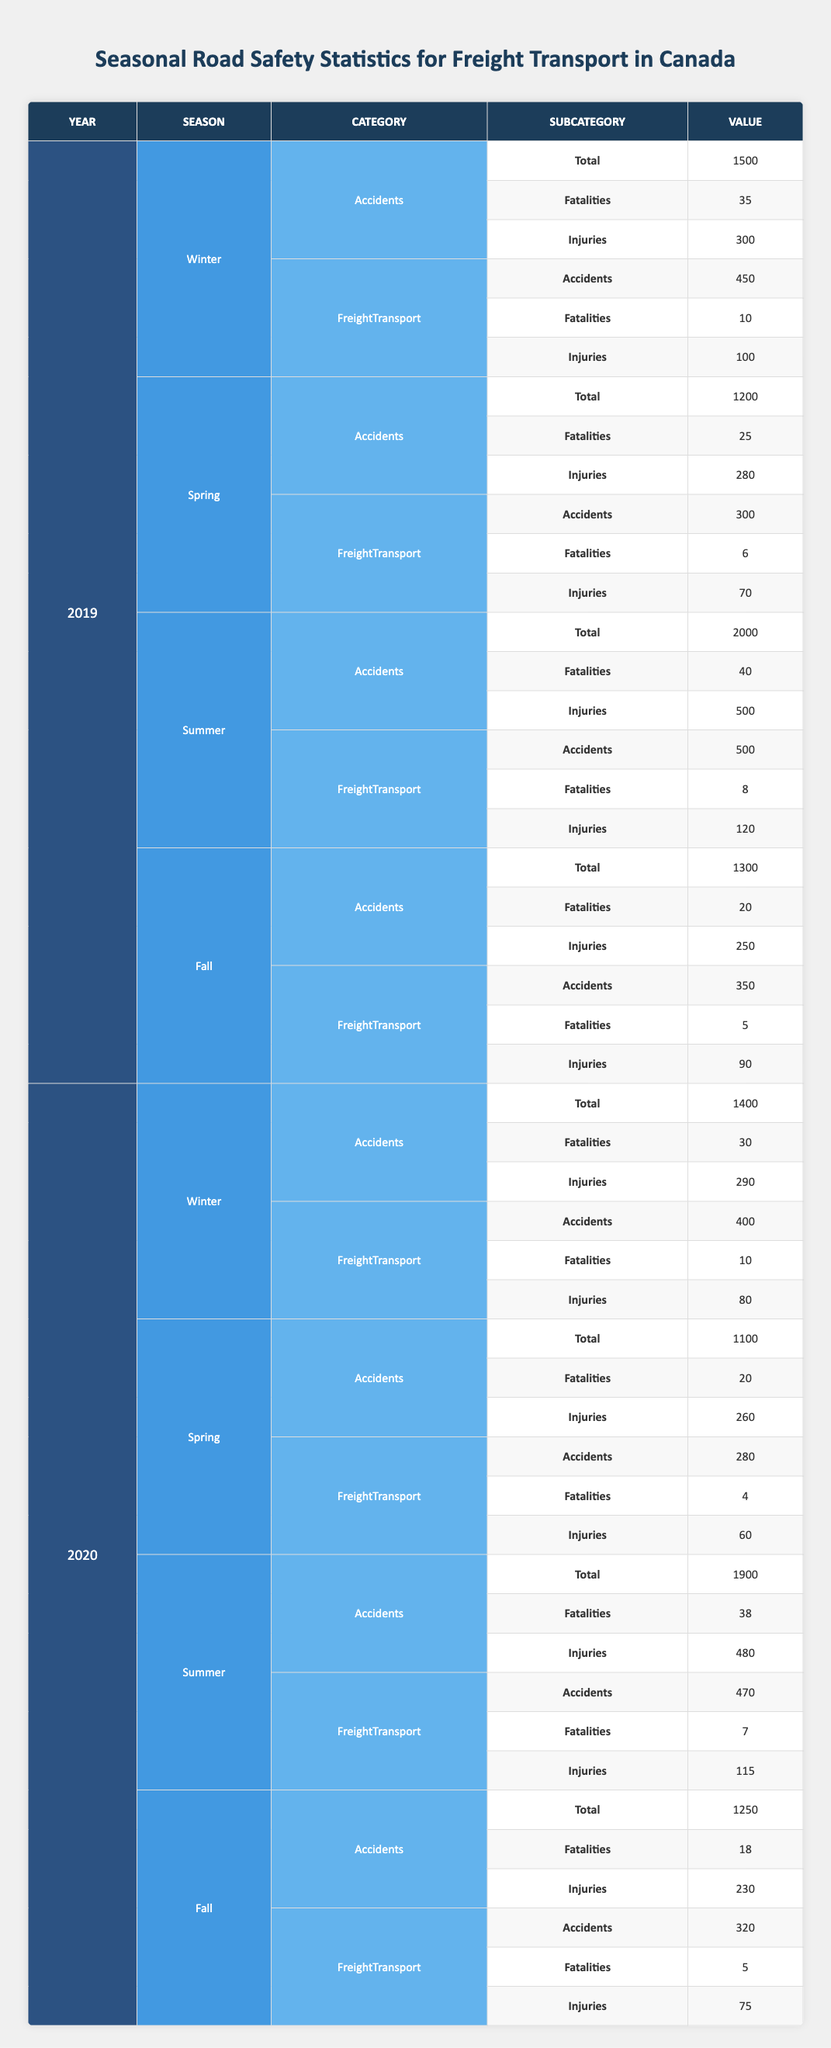What was the total number of freight transport accidents in summer 2019? In summer 2019, the table shows that the number of freight transport accidents was 500.
Answer: 500 How many fatalities were recorded for freight transport in winter 2020? According to the table, there were 10 fatalities in freight transport during winter 2020.
Answer: 10 What season had the highest number of total accidents in 2020? Looking at the total accidents for 2020 in each season, summer had the highest number with 1900 accidents.
Answer: Summer What is the total number of injuries from freight transport in 2019 across all seasons? Summing the injuries from freight transport in 2019: winter (100) + spring (70) + summer (120) + fall (90) gives a total of 380 injuries.
Answer: 380 Was there a decrease in the number of freight transport accidents from 2019 to 2020? By comparing the total freight transport accidents, 2019 had 1600 accidents (450 + 300 + 500 + 350) and 2020 had 1470 accidents (400 + 280 + 470 + 320), indicating a decrease.
Answer: Yes What was the average number of injuries in freight transport during fall across both years? The injuries in fall were 90 in 2019 and 75 in 2020. To calculate the average: (90 + 75) / 2 = 82.5.
Answer: 82.5 In which season did freight transport experience the lowest number of fatalities in 2019? In 2019, the lowest fatalities in freight transport were seen in fall with 5 fatalities.
Answer: Fall What was the overall percentage change in total accidents from 2019 to 2020? Total accidents for 2019 were 6200 (1500 + 1200 + 2000 + 1300) and for 2020 were 5650 (1400 + 1100 + 1900 + 1250). Percentage change is calculated as: ((6200 - 5650) / 6200) * 100 = 8.87%.
Answer: 8.87% Did the winter season in 2020 have more accidents than the winter season in 2019? The table indicates that winter 2019 had 1500 total accidents, while winter 2020 saw 1400 accidents, meaning there were fewer accidents in 2020.
Answer: No 